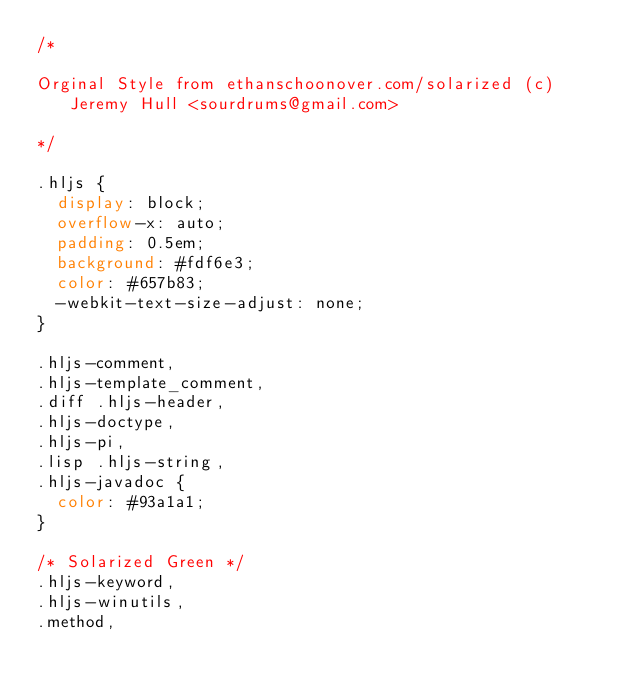<code> <loc_0><loc_0><loc_500><loc_500><_CSS_>/*

Orginal Style from ethanschoonover.com/solarized (c) Jeremy Hull <sourdrums@gmail.com>

*/

.hljs {
  display: block;
  overflow-x: auto;
  padding: 0.5em;
  background: #fdf6e3;
  color: #657b83;
  -webkit-text-size-adjust: none;
}

.hljs-comment,
.hljs-template_comment,
.diff .hljs-header,
.hljs-doctype,
.hljs-pi,
.lisp .hljs-string,
.hljs-javadoc {
  color: #93a1a1;
}

/* Solarized Green */
.hljs-keyword,
.hljs-winutils,
.method,</code> 